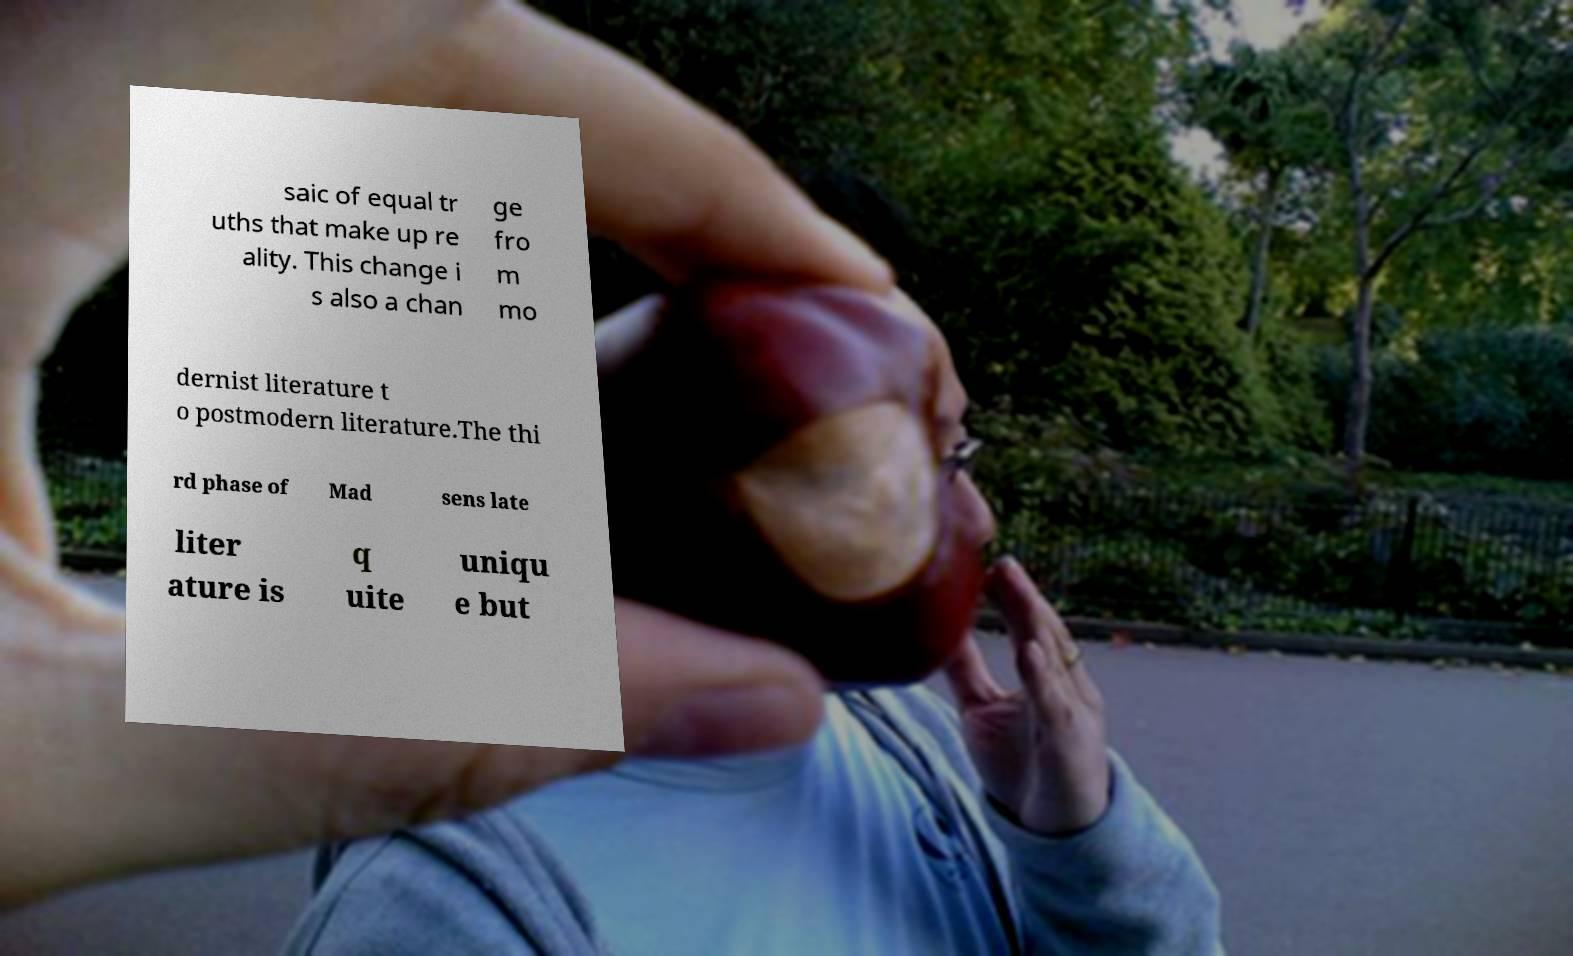Please identify and transcribe the text found in this image. saic of equal tr uths that make up re ality. This change i s also a chan ge fro m mo dernist literature t o postmodern literature.The thi rd phase of Mad sens late liter ature is q uite uniqu e but 